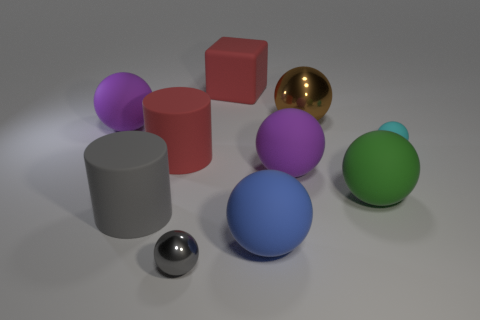Subtract all green spheres. How many spheres are left? 6 Subtract all tiny gray metal balls. How many balls are left? 6 Subtract 4 balls. How many balls are left? 3 Subtract all red spheres. Subtract all brown blocks. How many spheres are left? 7 Subtract all balls. How many objects are left? 3 Subtract 0 brown cylinders. How many objects are left? 10 Subtract all big cubes. Subtract all large metal things. How many objects are left? 8 Add 2 big purple matte things. How many big purple matte things are left? 4 Add 1 large yellow rubber objects. How many large yellow rubber objects exist? 1 